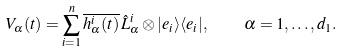<formula> <loc_0><loc_0><loc_500><loc_500>V _ { \alpha } ( t ) = \sum _ { i = 1 } ^ { n } \overline { h ^ { i } _ { \alpha } ( t ) } \, \hat { L } ^ { i } _ { \alpha } \otimes | e _ { i } \rangle \langle e _ { i } | , \quad \alpha = 1 , \dots , d _ { 1 } .</formula> 